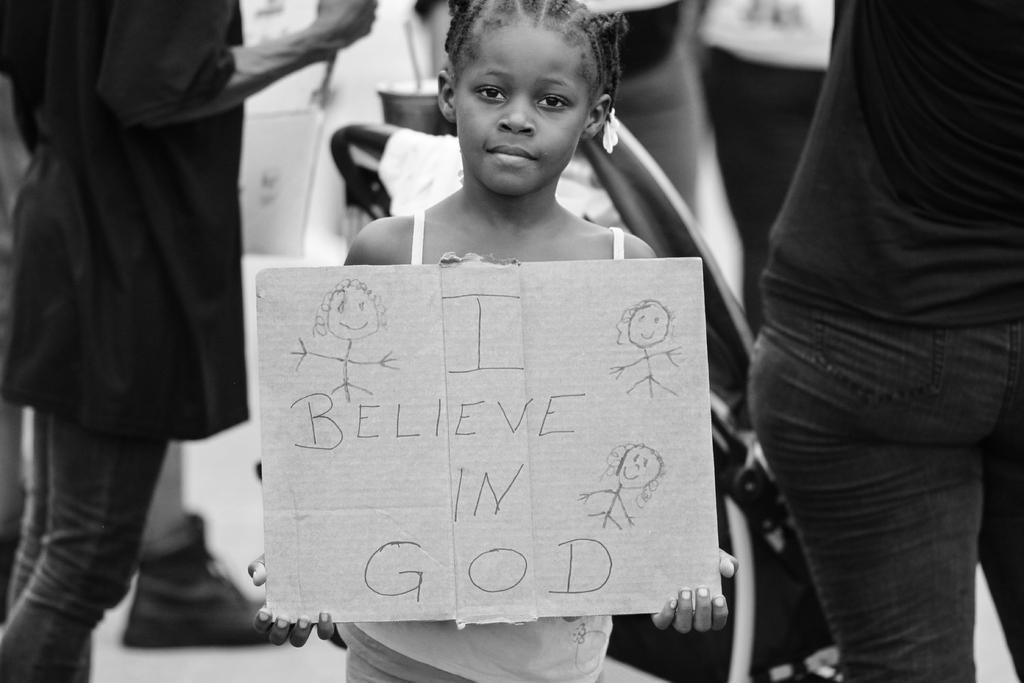Please provide a concise description of this image. In the picture there is a girl holding a board with the text, behind the girl there are people standing. 